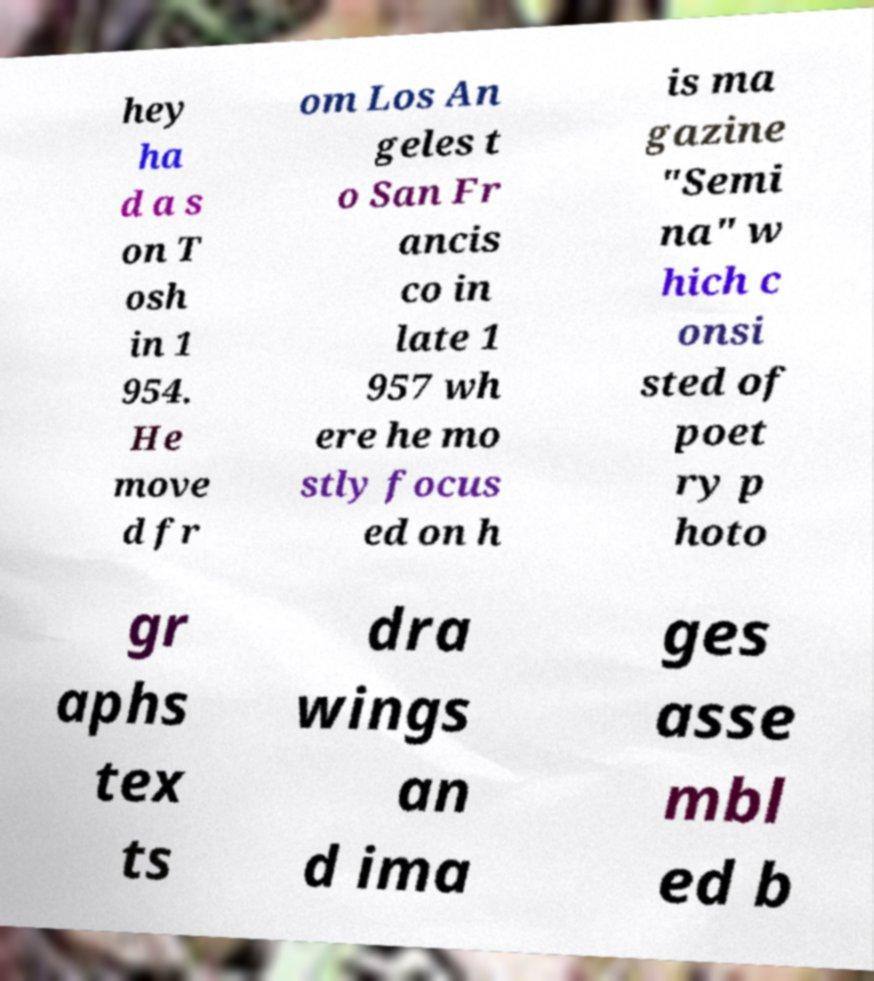There's text embedded in this image that I need extracted. Can you transcribe it verbatim? hey ha d a s on T osh in 1 954. He move d fr om Los An geles t o San Fr ancis co in late 1 957 wh ere he mo stly focus ed on h is ma gazine "Semi na" w hich c onsi sted of poet ry p hoto gr aphs tex ts dra wings an d ima ges asse mbl ed b 